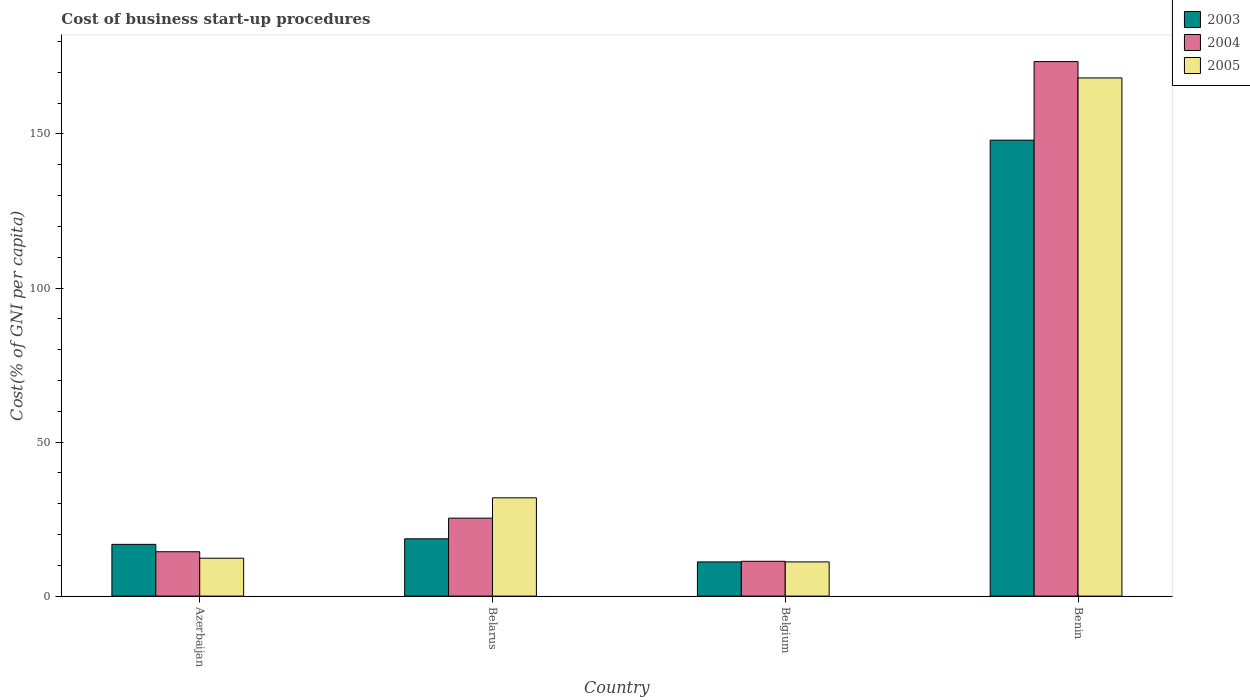How many different coloured bars are there?
Provide a short and direct response. 3. Are the number of bars on each tick of the X-axis equal?
Your answer should be compact. Yes. How many bars are there on the 1st tick from the right?
Your answer should be very brief. 3. What is the cost of business start-up procedures in 2005 in Belarus?
Provide a succinct answer. 31.9. Across all countries, what is the maximum cost of business start-up procedures in 2003?
Your answer should be compact. 148. In which country was the cost of business start-up procedures in 2003 maximum?
Provide a succinct answer. Benin. In which country was the cost of business start-up procedures in 2003 minimum?
Your answer should be very brief. Belgium. What is the total cost of business start-up procedures in 2005 in the graph?
Provide a succinct answer. 223.5. What is the difference between the cost of business start-up procedures in 2003 in Azerbaijan and that in Benin?
Give a very brief answer. -131.2. What is the difference between the cost of business start-up procedures in 2004 in Benin and the cost of business start-up procedures in 2005 in Azerbaijan?
Give a very brief answer. 161.2. What is the average cost of business start-up procedures in 2005 per country?
Offer a very short reply. 55.88. What is the difference between the cost of business start-up procedures of/in 2003 and cost of business start-up procedures of/in 2004 in Belarus?
Offer a very short reply. -6.7. In how many countries, is the cost of business start-up procedures in 2005 greater than 80 %?
Your answer should be compact. 1. What is the ratio of the cost of business start-up procedures in 2003 in Azerbaijan to that in Benin?
Your response must be concise. 0.11. What is the difference between the highest and the second highest cost of business start-up procedures in 2003?
Your response must be concise. -1.8. What is the difference between the highest and the lowest cost of business start-up procedures in 2003?
Give a very brief answer. 136.9. In how many countries, is the cost of business start-up procedures in 2004 greater than the average cost of business start-up procedures in 2004 taken over all countries?
Ensure brevity in your answer.  1. Is the sum of the cost of business start-up procedures in 2005 in Azerbaijan and Benin greater than the maximum cost of business start-up procedures in 2004 across all countries?
Give a very brief answer. Yes. What does the 3rd bar from the left in Belgium represents?
Offer a terse response. 2005. Is it the case that in every country, the sum of the cost of business start-up procedures in 2003 and cost of business start-up procedures in 2005 is greater than the cost of business start-up procedures in 2004?
Keep it short and to the point. Yes. How many bars are there?
Give a very brief answer. 12. Are all the bars in the graph horizontal?
Give a very brief answer. No. How many countries are there in the graph?
Your answer should be compact. 4. Are the values on the major ticks of Y-axis written in scientific E-notation?
Offer a very short reply. No. Does the graph contain grids?
Make the answer very short. No. Where does the legend appear in the graph?
Provide a short and direct response. Top right. What is the title of the graph?
Provide a succinct answer. Cost of business start-up procedures. Does "2011" appear as one of the legend labels in the graph?
Offer a terse response. No. What is the label or title of the X-axis?
Give a very brief answer. Country. What is the label or title of the Y-axis?
Offer a very short reply. Cost(% of GNI per capita). What is the Cost(% of GNI per capita) of 2005 in Azerbaijan?
Offer a very short reply. 12.3. What is the Cost(% of GNI per capita) in 2004 in Belarus?
Keep it short and to the point. 25.3. What is the Cost(% of GNI per capita) of 2005 in Belarus?
Give a very brief answer. 31.9. What is the Cost(% of GNI per capita) in 2003 in Belgium?
Provide a short and direct response. 11.1. What is the Cost(% of GNI per capita) in 2004 in Belgium?
Give a very brief answer. 11.3. What is the Cost(% of GNI per capita) of 2003 in Benin?
Provide a succinct answer. 148. What is the Cost(% of GNI per capita) of 2004 in Benin?
Offer a terse response. 173.5. What is the Cost(% of GNI per capita) of 2005 in Benin?
Provide a short and direct response. 168.2. Across all countries, what is the maximum Cost(% of GNI per capita) of 2003?
Make the answer very short. 148. Across all countries, what is the maximum Cost(% of GNI per capita) in 2004?
Make the answer very short. 173.5. Across all countries, what is the maximum Cost(% of GNI per capita) of 2005?
Make the answer very short. 168.2. Across all countries, what is the minimum Cost(% of GNI per capita) of 2003?
Ensure brevity in your answer.  11.1. What is the total Cost(% of GNI per capita) in 2003 in the graph?
Make the answer very short. 194.5. What is the total Cost(% of GNI per capita) of 2004 in the graph?
Your answer should be very brief. 224.5. What is the total Cost(% of GNI per capita) in 2005 in the graph?
Provide a succinct answer. 223.5. What is the difference between the Cost(% of GNI per capita) of 2005 in Azerbaijan and that in Belarus?
Keep it short and to the point. -19.6. What is the difference between the Cost(% of GNI per capita) of 2004 in Azerbaijan and that in Belgium?
Ensure brevity in your answer.  3.1. What is the difference between the Cost(% of GNI per capita) in 2005 in Azerbaijan and that in Belgium?
Keep it short and to the point. 1.2. What is the difference between the Cost(% of GNI per capita) of 2003 in Azerbaijan and that in Benin?
Offer a very short reply. -131.2. What is the difference between the Cost(% of GNI per capita) of 2004 in Azerbaijan and that in Benin?
Make the answer very short. -159.1. What is the difference between the Cost(% of GNI per capita) of 2005 in Azerbaijan and that in Benin?
Your response must be concise. -155.9. What is the difference between the Cost(% of GNI per capita) in 2003 in Belarus and that in Belgium?
Make the answer very short. 7.5. What is the difference between the Cost(% of GNI per capita) of 2004 in Belarus and that in Belgium?
Your answer should be very brief. 14. What is the difference between the Cost(% of GNI per capita) of 2005 in Belarus and that in Belgium?
Make the answer very short. 20.8. What is the difference between the Cost(% of GNI per capita) in 2003 in Belarus and that in Benin?
Provide a succinct answer. -129.4. What is the difference between the Cost(% of GNI per capita) of 2004 in Belarus and that in Benin?
Give a very brief answer. -148.2. What is the difference between the Cost(% of GNI per capita) of 2005 in Belarus and that in Benin?
Ensure brevity in your answer.  -136.3. What is the difference between the Cost(% of GNI per capita) of 2003 in Belgium and that in Benin?
Offer a terse response. -136.9. What is the difference between the Cost(% of GNI per capita) in 2004 in Belgium and that in Benin?
Ensure brevity in your answer.  -162.2. What is the difference between the Cost(% of GNI per capita) in 2005 in Belgium and that in Benin?
Your answer should be compact. -157.1. What is the difference between the Cost(% of GNI per capita) in 2003 in Azerbaijan and the Cost(% of GNI per capita) in 2005 in Belarus?
Offer a very short reply. -15.1. What is the difference between the Cost(% of GNI per capita) in 2004 in Azerbaijan and the Cost(% of GNI per capita) in 2005 in Belarus?
Offer a very short reply. -17.5. What is the difference between the Cost(% of GNI per capita) in 2003 in Azerbaijan and the Cost(% of GNI per capita) in 2004 in Belgium?
Offer a very short reply. 5.5. What is the difference between the Cost(% of GNI per capita) in 2003 in Azerbaijan and the Cost(% of GNI per capita) in 2005 in Belgium?
Make the answer very short. 5.7. What is the difference between the Cost(% of GNI per capita) in 2003 in Azerbaijan and the Cost(% of GNI per capita) in 2004 in Benin?
Your response must be concise. -156.7. What is the difference between the Cost(% of GNI per capita) in 2003 in Azerbaijan and the Cost(% of GNI per capita) in 2005 in Benin?
Your answer should be very brief. -151.4. What is the difference between the Cost(% of GNI per capita) of 2004 in Azerbaijan and the Cost(% of GNI per capita) of 2005 in Benin?
Ensure brevity in your answer.  -153.8. What is the difference between the Cost(% of GNI per capita) in 2003 in Belarus and the Cost(% of GNI per capita) in 2004 in Belgium?
Provide a succinct answer. 7.3. What is the difference between the Cost(% of GNI per capita) of 2003 in Belarus and the Cost(% of GNI per capita) of 2005 in Belgium?
Provide a short and direct response. 7.5. What is the difference between the Cost(% of GNI per capita) in 2003 in Belarus and the Cost(% of GNI per capita) in 2004 in Benin?
Your answer should be very brief. -154.9. What is the difference between the Cost(% of GNI per capita) of 2003 in Belarus and the Cost(% of GNI per capita) of 2005 in Benin?
Offer a very short reply. -149.6. What is the difference between the Cost(% of GNI per capita) of 2004 in Belarus and the Cost(% of GNI per capita) of 2005 in Benin?
Keep it short and to the point. -142.9. What is the difference between the Cost(% of GNI per capita) in 2003 in Belgium and the Cost(% of GNI per capita) in 2004 in Benin?
Your answer should be very brief. -162.4. What is the difference between the Cost(% of GNI per capita) in 2003 in Belgium and the Cost(% of GNI per capita) in 2005 in Benin?
Provide a short and direct response. -157.1. What is the difference between the Cost(% of GNI per capita) in 2004 in Belgium and the Cost(% of GNI per capita) in 2005 in Benin?
Your answer should be very brief. -156.9. What is the average Cost(% of GNI per capita) of 2003 per country?
Ensure brevity in your answer.  48.62. What is the average Cost(% of GNI per capita) in 2004 per country?
Your response must be concise. 56.12. What is the average Cost(% of GNI per capita) in 2005 per country?
Give a very brief answer. 55.88. What is the difference between the Cost(% of GNI per capita) in 2003 and Cost(% of GNI per capita) in 2004 in Azerbaijan?
Your answer should be very brief. 2.4. What is the difference between the Cost(% of GNI per capita) of 2003 and Cost(% of GNI per capita) of 2005 in Belarus?
Give a very brief answer. -13.3. What is the difference between the Cost(% of GNI per capita) in 2004 and Cost(% of GNI per capita) in 2005 in Belarus?
Provide a short and direct response. -6.6. What is the difference between the Cost(% of GNI per capita) of 2003 and Cost(% of GNI per capita) of 2004 in Belgium?
Provide a succinct answer. -0.2. What is the difference between the Cost(% of GNI per capita) of 2004 and Cost(% of GNI per capita) of 2005 in Belgium?
Offer a very short reply. 0.2. What is the difference between the Cost(% of GNI per capita) of 2003 and Cost(% of GNI per capita) of 2004 in Benin?
Your answer should be very brief. -25.5. What is the difference between the Cost(% of GNI per capita) in 2003 and Cost(% of GNI per capita) in 2005 in Benin?
Provide a short and direct response. -20.2. What is the difference between the Cost(% of GNI per capita) in 2004 and Cost(% of GNI per capita) in 2005 in Benin?
Offer a very short reply. 5.3. What is the ratio of the Cost(% of GNI per capita) of 2003 in Azerbaijan to that in Belarus?
Your answer should be compact. 0.9. What is the ratio of the Cost(% of GNI per capita) of 2004 in Azerbaijan to that in Belarus?
Provide a short and direct response. 0.57. What is the ratio of the Cost(% of GNI per capita) of 2005 in Azerbaijan to that in Belarus?
Make the answer very short. 0.39. What is the ratio of the Cost(% of GNI per capita) in 2003 in Azerbaijan to that in Belgium?
Your answer should be very brief. 1.51. What is the ratio of the Cost(% of GNI per capita) in 2004 in Azerbaijan to that in Belgium?
Give a very brief answer. 1.27. What is the ratio of the Cost(% of GNI per capita) in 2005 in Azerbaijan to that in Belgium?
Offer a terse response. 1.11. What is the ratio of the Cost(% of GNI per capita) in 2003 in Azerbaijan to that in Benin?
Keep it short and to the point. 0.11. What is the ratio of the Cost(% of GNI per capita) of 2004 in Azerbaijan to that in Benin?
Ensure brevity in your answer.  0.08. What is the ratio of the Cost(% of GNI per capita) in 2005 in Azerbaijan to that in Benin?
Your answer should be very brief. 0.07. What is the ratio of the Cost(% of GNI per capita) of 2003 in Belarus to that in Belgium?
Offer a very short reply. 1.68. What is the ratio of the Cost(% of GNI per capita) in 2004 in Belarus to that in Belgium?
Your answer should be compact. 2.24. What is the ratio of the Cost(% of GNI per capita) in 2005 in Belarus to that in Belgium?
Your answer should be very brief. 2.87. What is the ratio of the Cost(% of GNI per capita) in 2003 in Belarus to that in Benin?
Your answer should be compact. 0.13. What is the ratio of the Cost(% of GNI per capita) of 2004 in Belarus to that in Benin?
Offer a very short reply. 0.15. What is the ratio of the Cost(% of GNI per capita) in 2005 in Belarus to that in Benin?
Your response must be concise. 0.19. What is the ratio of the Cost(% of GNI per capita) of 2003 in Belgium to that in Benin?
Your answer should be very brief. 0.07. What is the ratio of the Cost(% of GNI per capita) of 2004 in Belgium to that in Benin?
Provide a succinct answer. 0.07. What is the ratio of the Cost(% of GNI per capita) in 2005 in Belgium to that in Benin?
Make the answer very short. 0.07. What is the difference between the highest and the second highest Cost(% of GNI per capita) of 2003?
Your answer should be compact. 129.4. What is the difference between the highest and the second highest Cost(% of GNI per capita) of 2004?
Give a very brief answer. 148.2. What is the difference between the highest and the second highest Cost(% of GNI per capita) of 2005?
Make the answer very short. 136.3. What is the difference between the highest and the lowest Cost(% of GNI per capita) in 2003?
Provide a succinct answer. 136.9. What is the difference between the highest and the lowest Cost(% of GNI per capita) in 2004?
Offer a terse response. 162.2. What is the difference between the highest and the lowest Cost(% of GNI per capita) of 2005?
Keep it short and to the point. 157.1. 